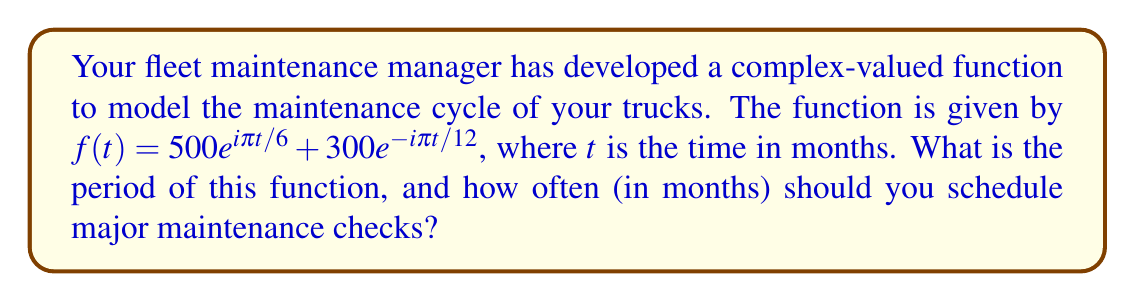Give your solution to this math problem. Let's approach this step-by-step:

1) The function $f(t) = 500e^{i\pi t/6} + 300e^{-i\pi t/12}$ is a sum of two complex exponentials.

2) To find the period of this function, we need to find the least common multiple (LCM) of the periods of each term.

3) For the first term, $500e^{i\pi t/6}$:
   The exponent completes a full rotation when $\frac{\pi t}{6} = 2\pi$
   Solving for $t$: $t = 12$ months

4) For the second term, $300e^{-i\pi t/12}$:
   The exponent completes a full rotation when $\frac{\pi t}{12} = 2\pi$
   Solving for $t$: $t = 24$ months

5) The period of the entire function is the LCM of 12 and 24, which is 24 months.

6) Therefore, the function repeats every 24 months, which means major maintenance checks should be scheduled every 24 months to align with the complete cycle of the maintenance model.
Answer: 24 months 